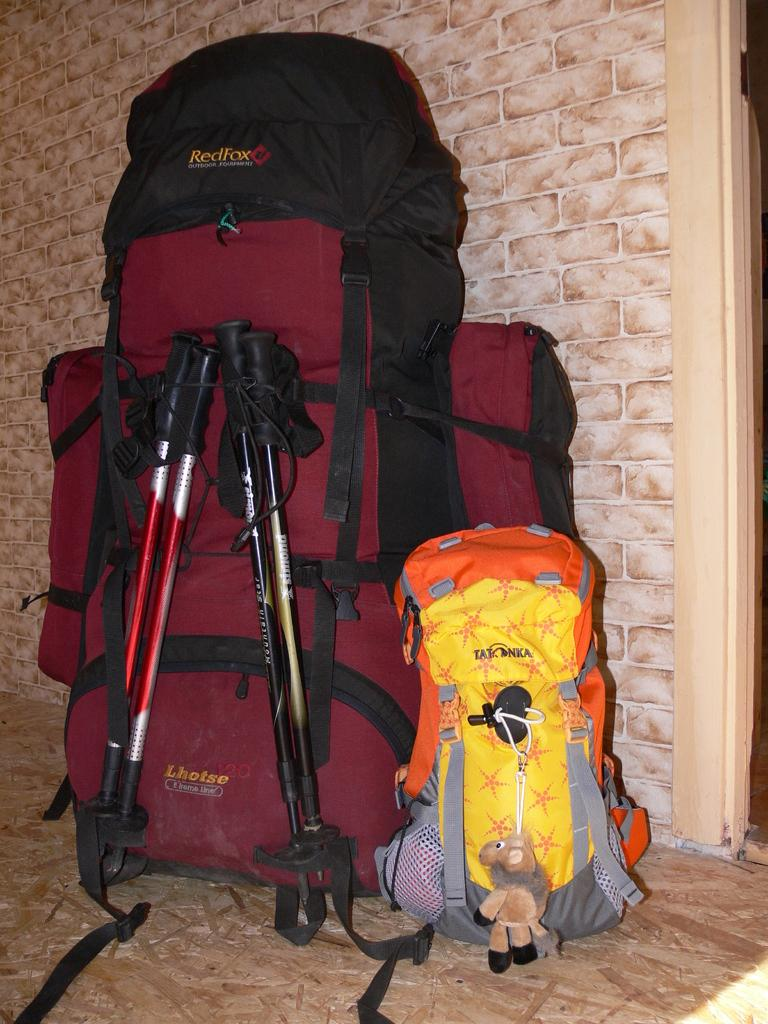<image>
Relay a brief, clear account of the picture shown. A red Lhotse backpack with two ski poles folded up and attached to the back. 